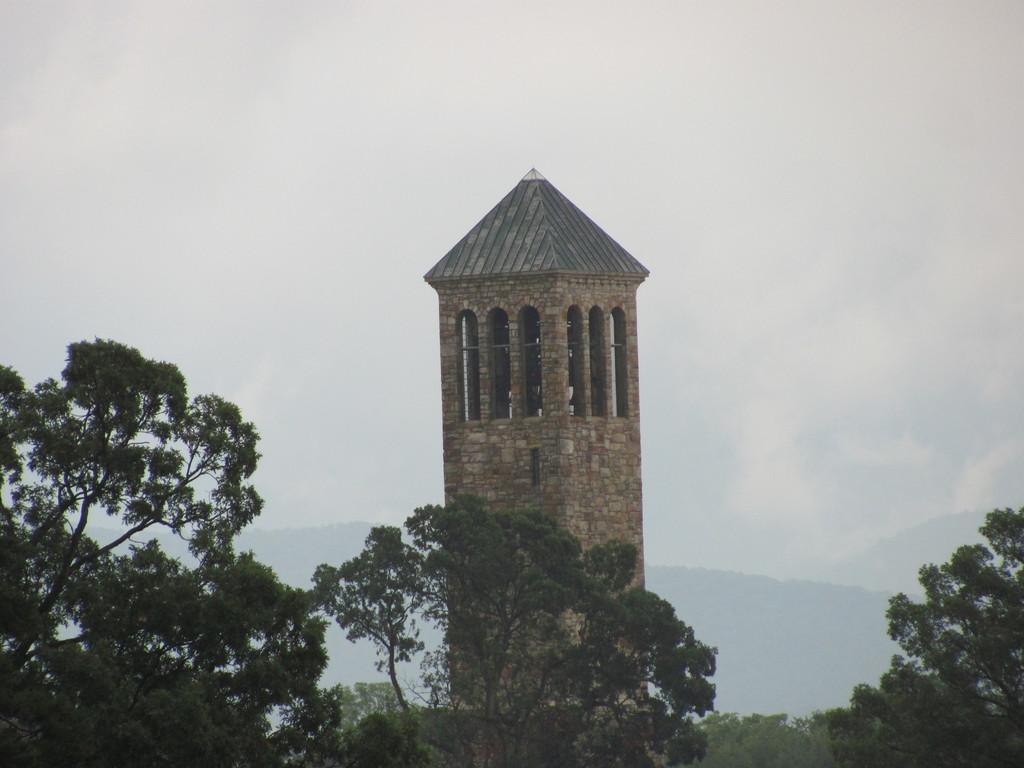How would you summarize this image in a sentence or two? In the middle it is a structure. On the left side there are trees. 